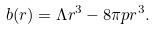Convert formula to latex. <formula><loc_0><loc_0><loc_500><loc_500>b ( r ) = \Lambda r ^ { 3 } - 8 \pi p r ^ { 3 } .</formula> 